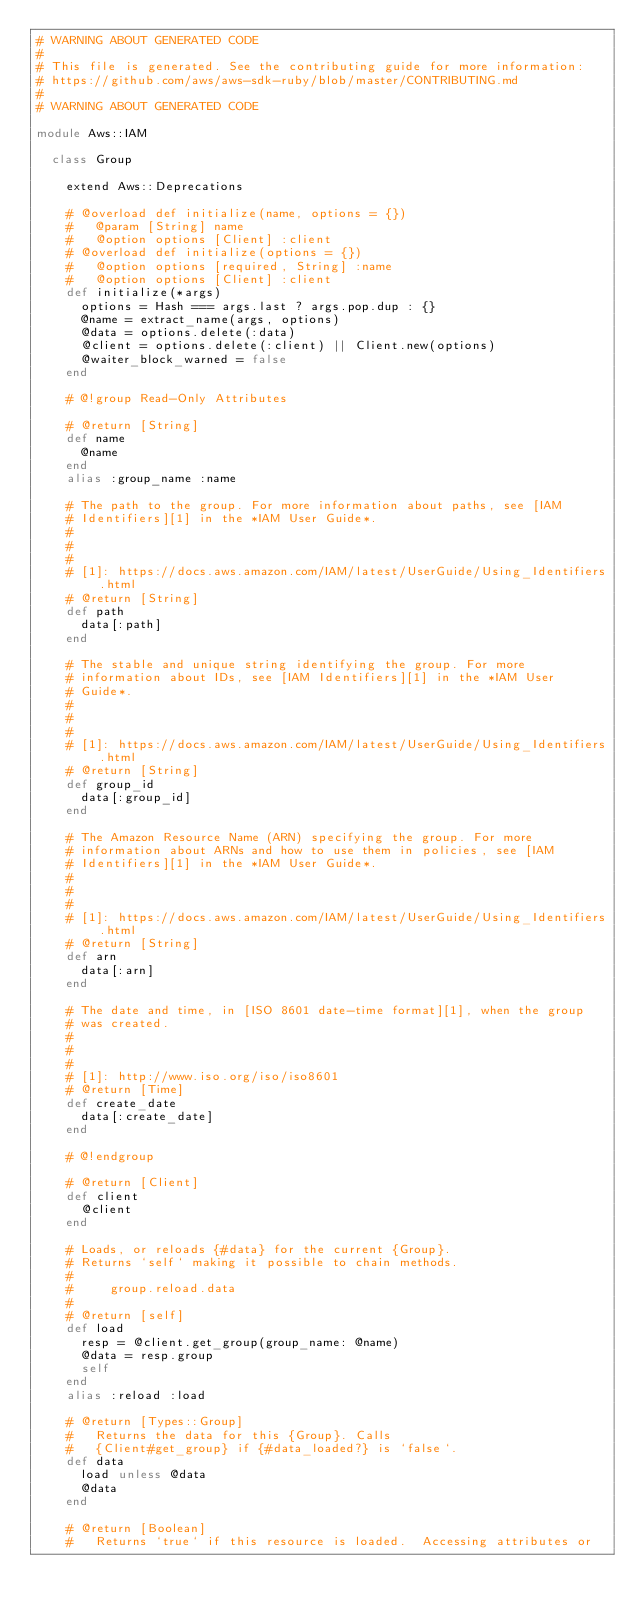Convert code to text. <code><loc_0><loc_0><loc_500><loc_500><_Ruby_># WARNING ABOUT GENERATED CODE
#
# This file is generated. See the contributing guide for more information:
# https://github.com/aws/aws-sdk-ruby/blob/master/CONTRIBUTING.md
#
# WARNING ABOUT GENERATED CODE

module Aws::IAM

  class Group

    extend Aws::Deprecations

    # @overload def initialize(name, options = {})
    #   @param [String] name
    #   @option options [Client] :client
    # @overload def initialize(options = {})
    #   @option options [required, String] :name
    #   @option options [Client] :client
    def initialize(*args)
      options = Hash === args.last ? args.pop.dup : {}
      @name = extract_name(args, options)
      @data = options.delete(:data)
      @client = options.delete(:client) || Client.new(options)
      @waiter_block_warned = false
    end

    # @!group Read-Only Attributes

    # @return [String]
    def name
      @name
    end
    alias :group_name :name

    # The path to the group. For more information about paths, see [IAM
    # Identifiers][1] in the *IAM User Guide*.
    #
    #
    #
    # [1]: https://docs.aws.amazon.com/IAM/latest/UserGuide/Using_Identifiers.html
    # @return [String]
    def path
      data[:path]
    end

    # The stable and unique string identifying the group. For more
    # information about IDs, see [IAM Identifiers][1] in the *IAM User
    # Guide*.
    #
    #
    #
    # [1]: https://docs.aws.amazon.com/IAM/latest/UserGuide/Using_Identifiers.html
    # @return [String]
    def group_id
      data[:group_id]
    end

    # The Amazon Resource Name (ARN) specifying the group. For more
    # information about ARNs and how to use them in policies, see [IAM
    # Identifiers][1] in the *IAM User Guide*.
    #
    #
    #
    # [1]: https://docs.aws.amazon.com/IAM/latest/UserGuide/Using_Identifiers.html
    # @return [String]
    def arn
      data[:arn]
    end

    # The date and time, in [ISO 8601 date-time format][1], when the group
    # was created.
    #
    #
    #
    # [1]: http://www.iso.org/iso/iso8601
    # @return [Time]
    def create_date
      data[:create_date]
    end

    # @!endgroup

    # @return [Client]
    def client
      @client
    end

    # Loads, or reloads {#data} for the current {Group}.
    # Returns `self` making it possible to chain methods.
    #
    #     group.reload.data
    #
    # @return [self]
    def load
      resp = @client.get_group(group_name: @name)
      @data = resp.group
      self
    end
    alias :reload :load

    # @return [Types::Group]
    #   Returns the data for this {Group}. Calls
    #   {Client#get_group} if {#data_loaded?} is `false`.
    def data
      load unless @data
      @data
    end

    # @return [Boolean]
    #   Returns `true` if this resource is loaded.  Accessing attributes or</code> 